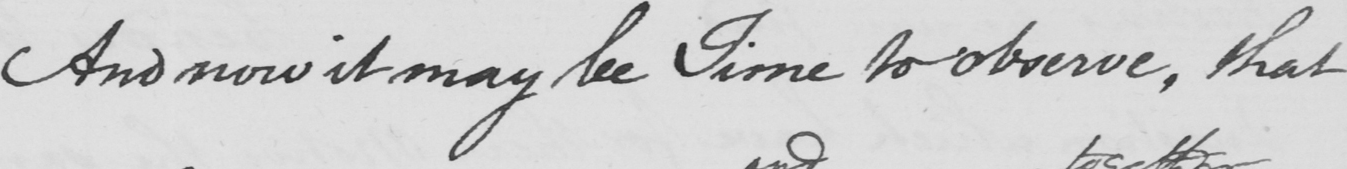Can you tell me what this handwritten text says? And now it may be Time to observe , that 